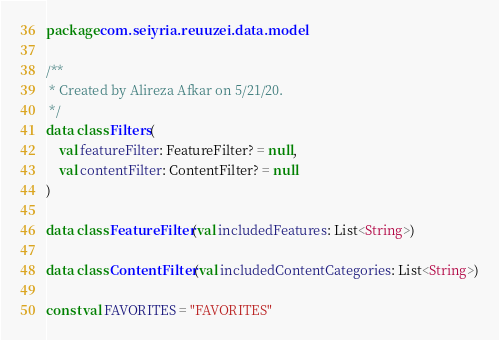Convert code to text. <code><loc_0><loc_0><loc_500><loc_500><_Kotlin_>package com.seiyria.reuuzei.data.model

/**
 * Created by Alireza Afkar on 5/21/20.
 */
data class Filters(
    val featureFilter: FeatureFilter? = null,
    val contentFilter: ContentFilter? = null
)

data class FeatureFilter(val includedFeatures: List<String>)

data class ContentFilter(val includedContentCategories: List<String>)

const val FAVORITES = "FAVORITES"
</code> 